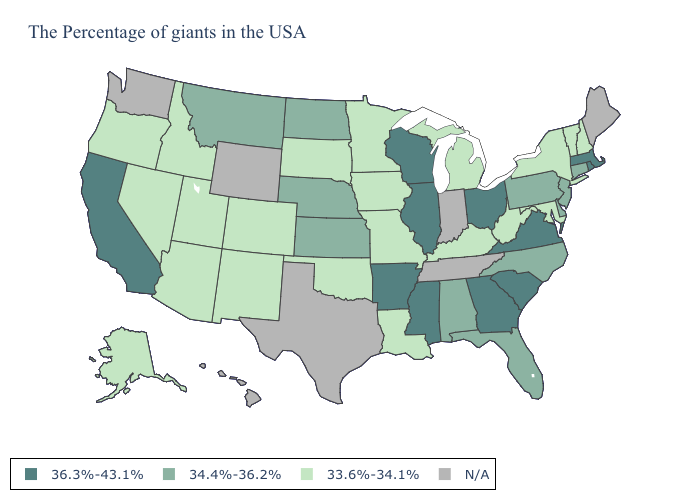Name the states that have a value in the range N/A?
Keep it brief. Maine, Indiana, Tennessee, Texas, Wyoming, Washington, Hawaii. What is the value of Illinois?
Short answer required. 36.3%-43.1%. Name the states that have a value in the range 33.6%-34.1%?
Write a very short answer. New Hampshire, Vermont, New York, Maryland, West Virginia, Michigan, Kentucky, Louisiana, Missouri, Minnesota, Iowa, Oklahoma, South Dakota, Colorado, New Mexico, Utah, Arizona, Idaho, Nevada, Oregon, Alaska. Name the states that have a value in the range N/A?
Quick response, please. Maine, Indiana, Tennessee, Texas, Wyoming, Washington, Hawaii. Name the states that have a value in the range 33.6%-34.1%?
Quick response, please. New Hampshire, Vermont, New York, Maryland, West Virginia, Michigan, Kentucky, Louisiana, Missouri, Minnesota, Iowa, Oklahoma, South Dakota, Colorado, New Mexico, Utah, Arizona, Idaho, Nevada, Oregon, Alaska. Name the states that have a value in the range N/A?
Quick response, please. Maine, Indiana, Tennessee, Texas, Wyoming, Washington, Hawaii. Which states have the lowest value in the Northeast?
Write a very short answer. New Hampshire, Vermont, New York. Does the map have missing data?
Quick response, please. Yes. What is the value of Idaho?
Give a very brief answer. 33.6%-34.1%. Which states have the lowest value in the MidWest?
Give a very brief answer. Michigan, Missouri, Minnesota, Iowa, South Dakota. Among the states that border Iowa , which have the lowest value?
Answer briefly. Missouri, Minnesota, South Dakota. Name the states that have a value in the range N/A?
Keep it brief. Maine, Indiana, Tennessee, Texas, Wyoming, Washington, Hawaii. Name the states that have a value in the range 36.3%-43.1%?
Short answer required. Massachusetts, Rhode Island, Virginia, South Carolina, Ohio, Georgia, Wisconsin, Illinois, Mississippi, Arkansas, California. What is the lowest value in the West?
Be succinct. 33.6%-34.1%. 